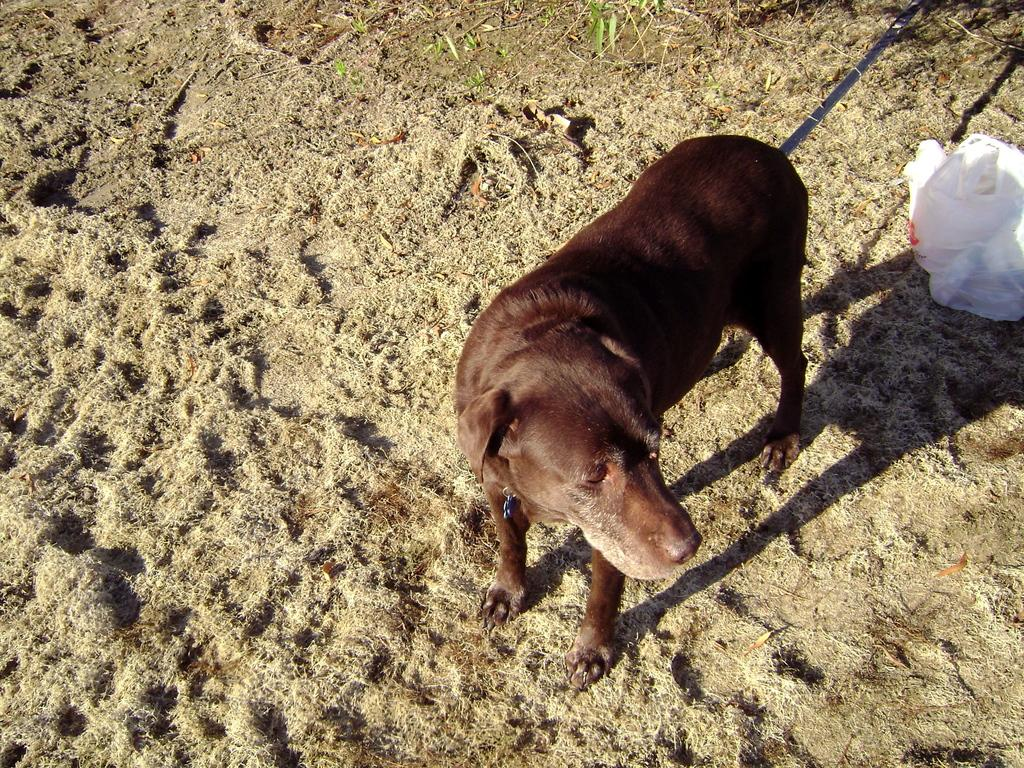What type of animal is present in the image? There is a dog in the image. What type of terrain can be seen in the image? There is sand and grass in the image. What object is located behind the dog? There is a polythene cover behind the dog. How many flies are sitting on the furniture in the image? There is no furniture present in the image, so it is not possible to determine the number of flies on it. 